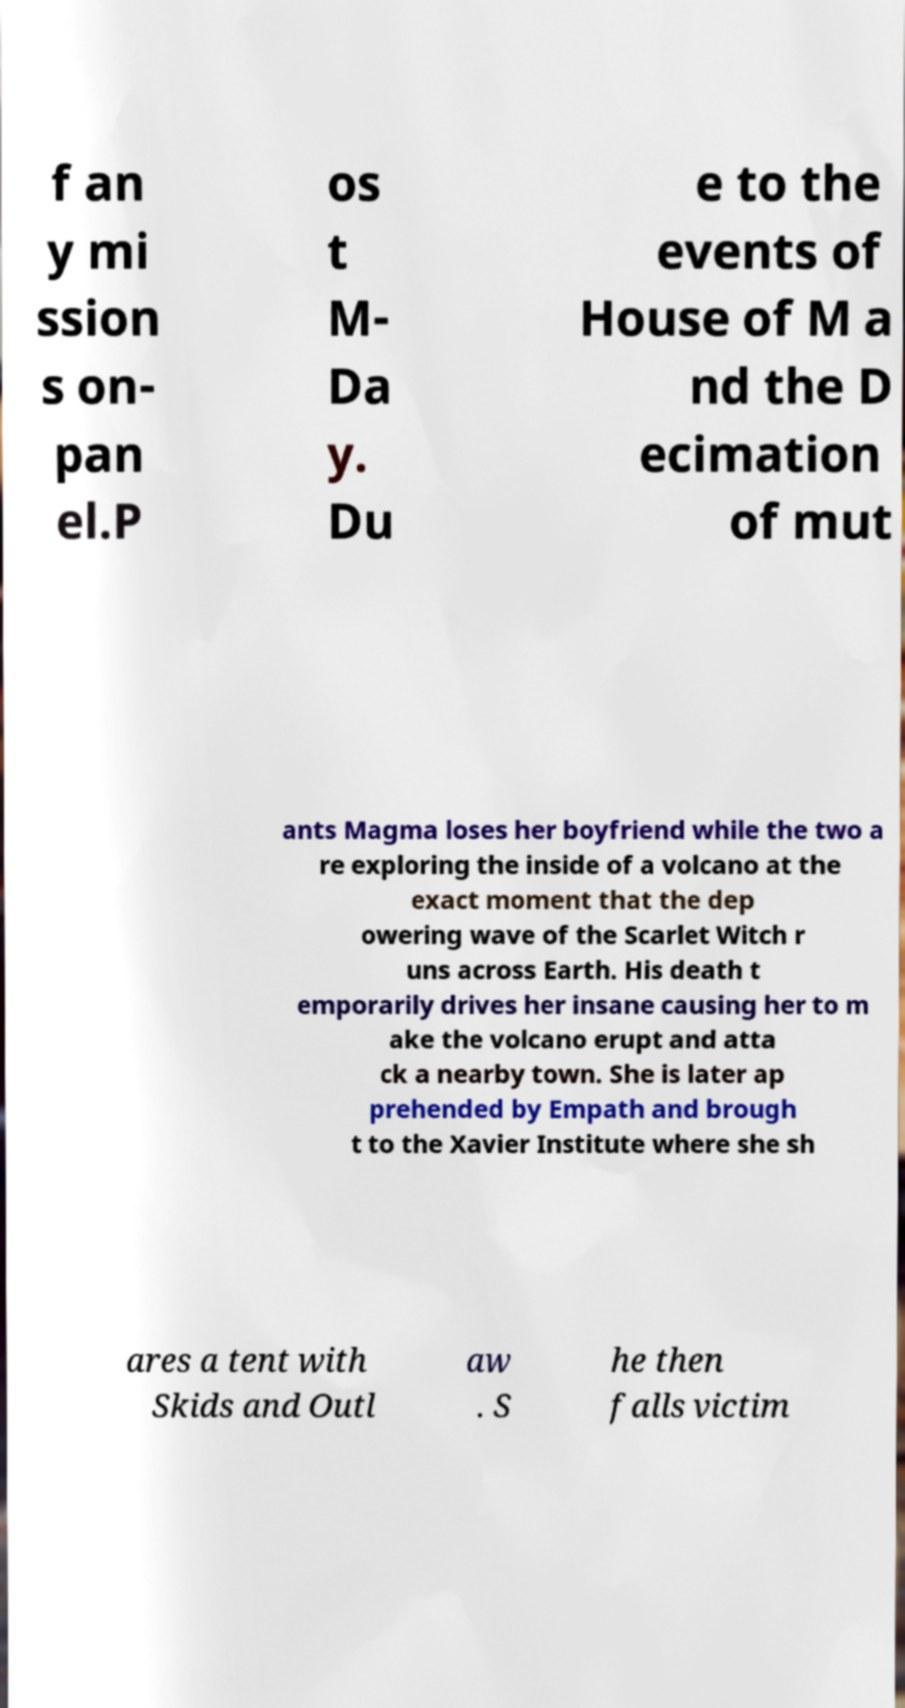Could you extract and type out the text from this image? f an y mi ssion s on- pan el.P os t M- Da y. Du e to the events of House of M a nd the D ecimation of mut ants Magma loses her boyfriend while the two a re exploring the inside of a volcano at the exact moment that the dep owering wave of the Scarlet Witch r uns across Earth. His death t emporarily drives her insane causing her to m ake the volcano erupt and atta ck a nearby town. She is later ap prehended by Empath and brough t to the Xavier Institute where she sh ares a tent with Skids and Outl aw . S he then falls victim 